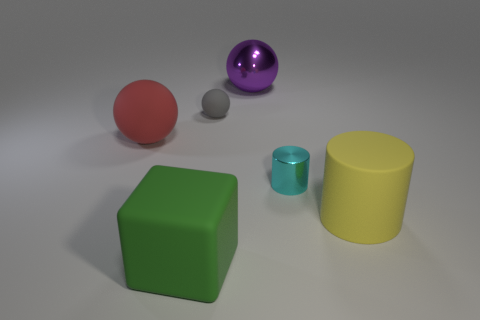Add 2 metallic cylinders. How many objects exist? 8 Subtract all cubes. How many objects are left? 5 Subtract all large metal things. Subtract all cyan shiny things. How many objects are left? 4 Add 1 cylinders. How many cylinders are left? 3 Add 5 purple matte things. How many purple matte things exist? 5 Subtract 0 brown spheres. How many objects are left? 6 